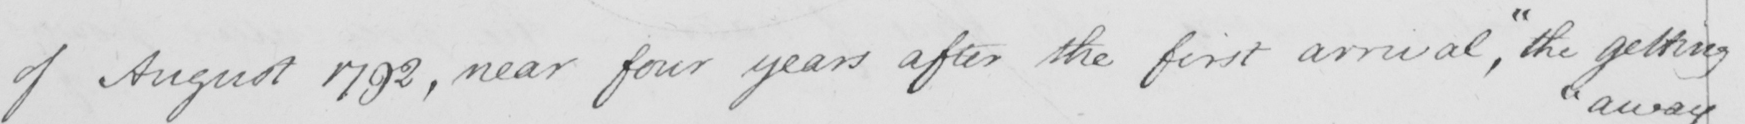Can you tell me what this handwritten text says? of August 1792 , near four years after the first arrival ,  " the getting 